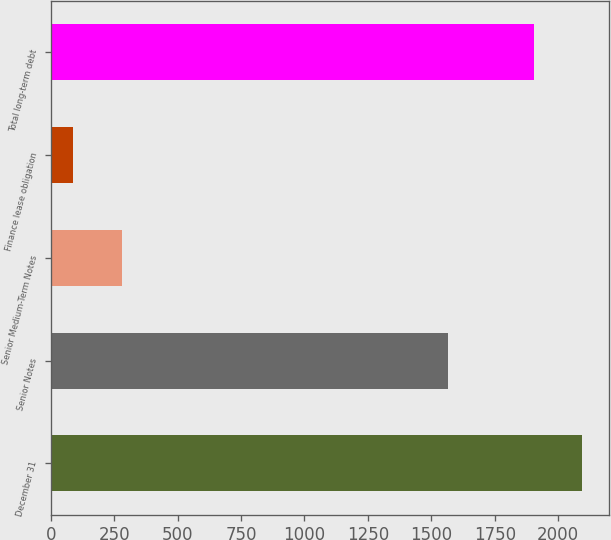Convert chart to OTSL. <chart><loc_0><loc_0><loc_500><loc_500><bar_chart><fcel>December 31<fcel>Senior Notes<fcel>Senior Medium-Term Notes<fcel>Finance lease obligation<fcel>Total long-term debt<nl><fcel>2095.4<fcel>1565<fcel>281.4<fcel>89<fcel>1903<nl></chart> 